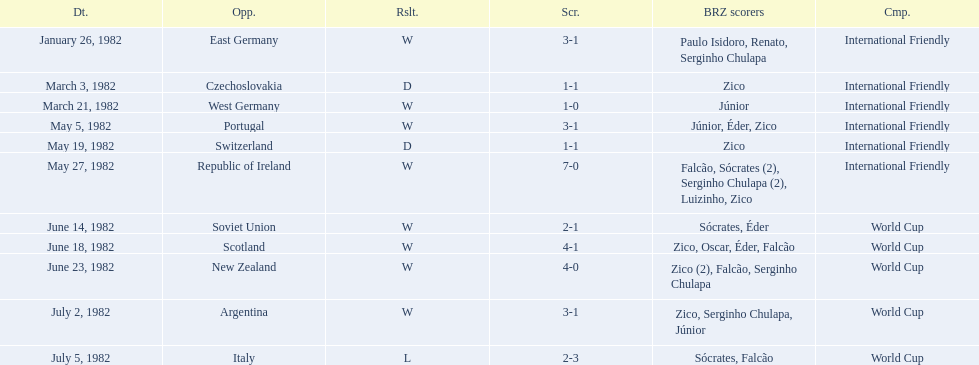What are the dates? January 26, 1982, March 3, 1982, March 21, 1982, May 5, 1982, May 19, 1982, May 27, 1982, June 14, 1982, June 18, 1982, June 23, 1982, July 2, 1982, July 5, 1982. And which date is listed first? January 26, 1982. 